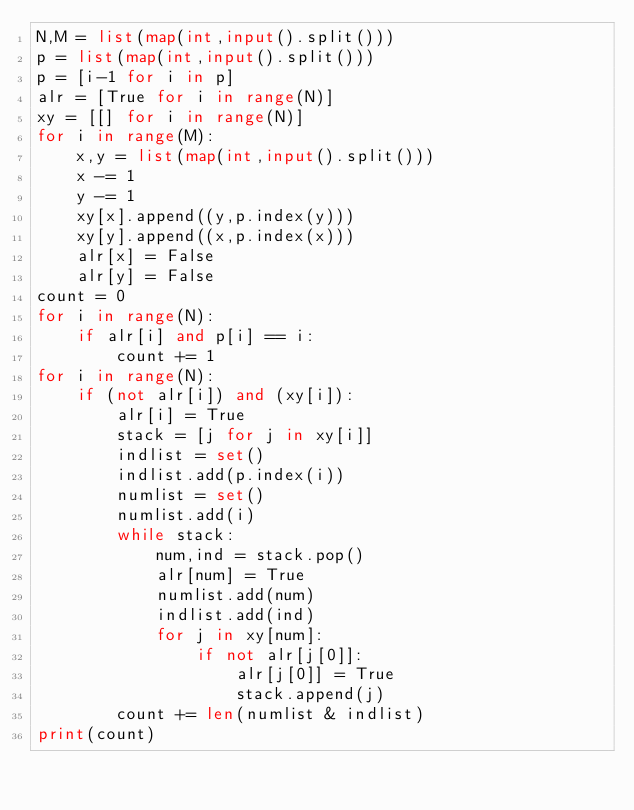<code> <loc_0><loc_0><loc_500><loc_500><_Python_>N,M = list(map(int,input().split()))
p = list(map(int,input().split()))
p = [i-1 for i in p]
alr = [True for i in range(N)]
xy = [[] for i in range(N)]
for i in range(M):
    x,y = list(map(int,input().split()))
    x -= 1
    y -= 1
    xy[x].append((y,p.index(y)))
    xy[y].append((x,p.index(x)))
    alr[x] = False
    alr[y] = False
count = 0
for i in range(N):
    if alr[i] and p[i] == i:
        count += 1
for i in range(N):
    if (not alr[i]) and (xy[i]):
        alr[i] = True
        stack = [j for j in xy[i]]
        indlist = set()
        indlist.add(p.index(i))
        numlist = set()
        numlist.add(i)
        while stack:
            num,ind = stack.pop()
            alr[num] = True
            numlist.add(num)
            indlist.add(ind)
            for j in xy[num]:
                if not alr[j[0]]:
                    alr[j[0]] = True
                    stack.append(j)
        count += len(numlist & indlist)
print(count)</code> 